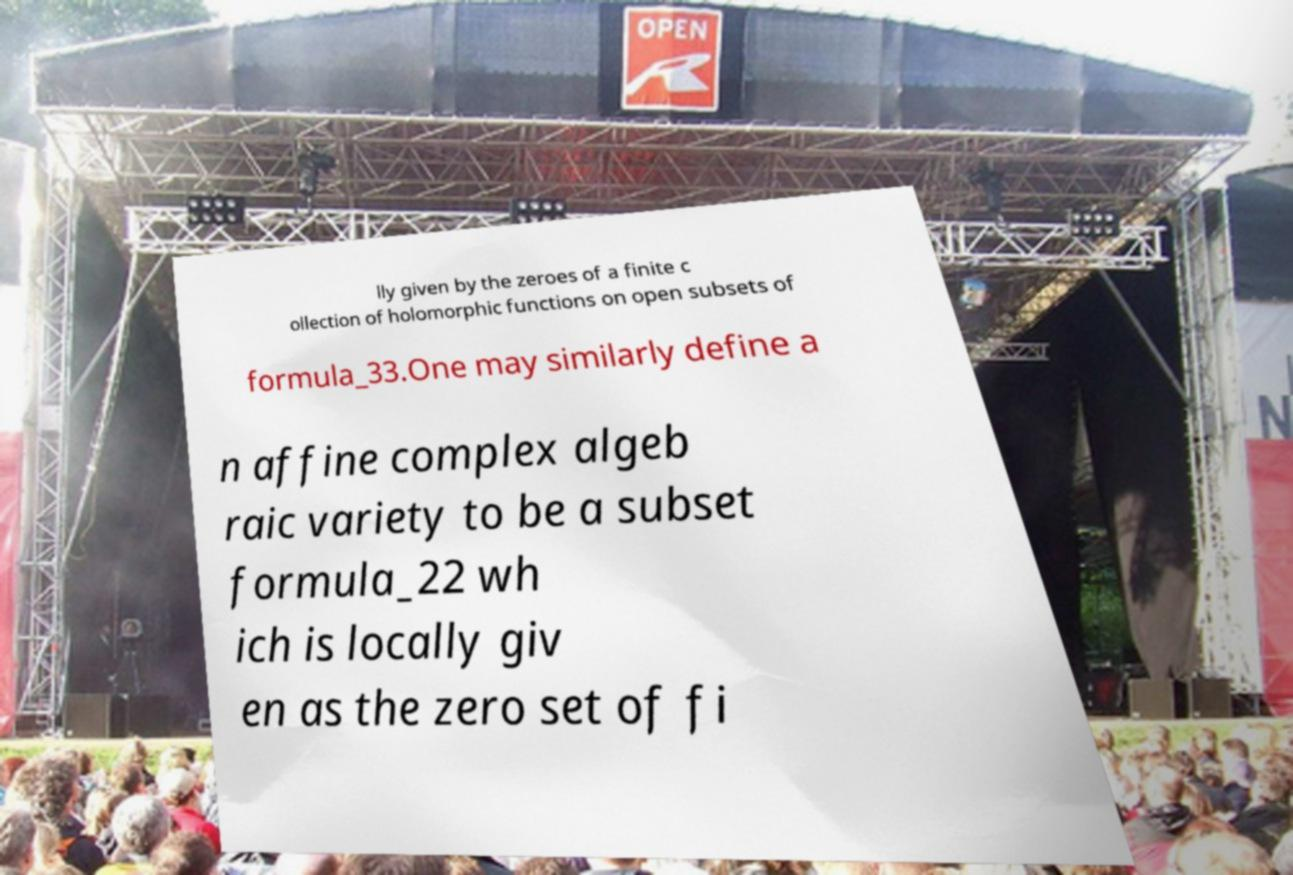Could you extract and type out the text from this image? lly given by the zeroes of a finite c ollection of holomorphic functions on open subsets of formula_33.One may similarly define a n affine complex algeb raic variety to be a subset formula_22 wh ich is locally giv en as the zero set of fi 